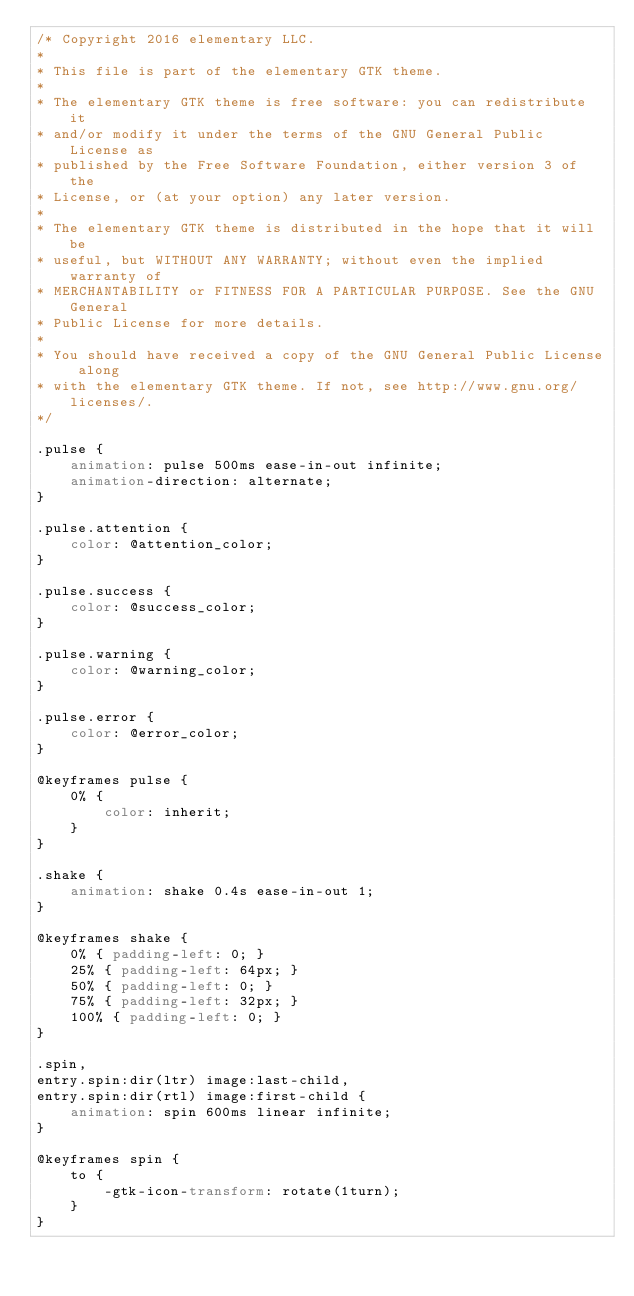<code> <loc_0><loc_0><loc_500><loc_500><_CSS_>/* Copyright 2016 elementary LLC.
*
* This file is part of the elementary GTK theme.
*
* The elementary GTK theme is free software: you can redistribute it
* and/or modify it under the terms of the GNU General Public License as
* published by the Free Software Foundation, either version 3 of the
* License, or (at your option) any later version.
*
* The elementary GTK theme is distributed in the hope that it will be
* useful, but WITHOUT ANY WARRANTY; without even the implied warranty of
* MERCHANTABILITY or FITNESS FOR A PARTICULAR PURPOSE. See the GNU General
* Public License for more details.
*
* You should have received a copy of the GNU General Public License along
* with the elementary GTK theme. If not, see http://www.gnu.org/licenses/.
*/

.pulse {
    animation: pulse 500ms ease-in-out infinite;
    animation-direction: alternate;
}

.pulse.attention {
    color: @attention_color;
}

.pulse.success {
    color: @success_color;
}

.pulse.warning {
    color: @warning_color;
}

.pulse.error {
    color: @error_color;
}

@keyframes pulse {
    0% {
        color: inherit;
    }
}

.shake {
    animation: shake 0.4s ease-in-out 1;
}

@keyframes shake {
    0% { padding-left: 0; }
    25% { padding-left: 64px; }
    50% { padding-left: 0; }
    75% { padding-left: 32px; }
    100% { padding-left: 0; }
}

.spin,
entry.spin:dir(ltr) image:last-child,
entry.spin:dir(rtl) image:first-child {
    animation: spin 600ms linear infinite;
}

@keyframes spin {
    to {
        -gtk-icon-transform: rotate(1turn);
    }
}
</code> 